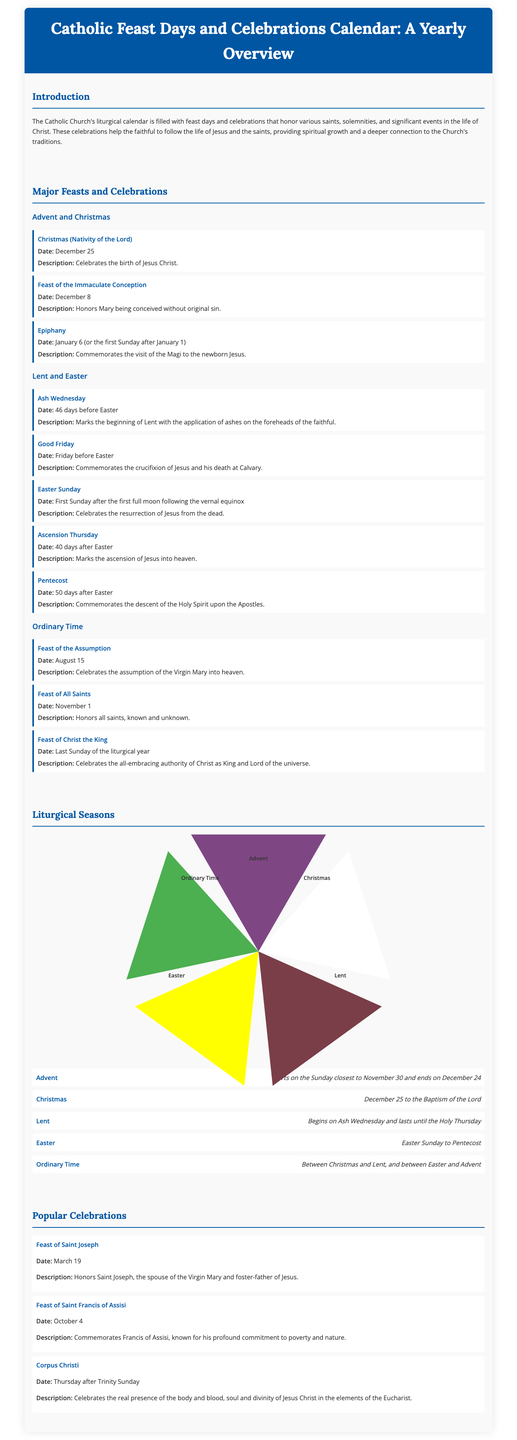what is the date of Christmas? Christmas is celebrated on December 25, as mentioned in the major feasts section.
Answer: December 25 what feast honors Mary being conceived without original sin? The feast that honors Mary is the Feast of the Immaculate Conception which occurs on December 8.
Answer: Feast of the Immaculate Conception how many days after Easter is Pentecost celebrated? Pentecost is celebrated 50 days after Easter according to the document's explanation.
Answer: 50 days which season starts on the Sunday closest to November 30? The season that starts on that date is Advent, as indicated in the liturgical seasons section.
Answer: Advent what is commemorated on Good Friday? Good Friday commemorates the crucifixion of Jesus and his death at Calvary, as outlined in the events.
Answer: Crucifixion of Jesus which feast is celebrated on August 15? The feast celebrated on this date is the Feast of the Assumption.
Answer: Feast of the Assumption when does Ordinary Time occur? Ordinary Time occurs between Christmas and Lent, and between Easter and Advent, as described in the liturgical seasons.
Answer: Between Christmas and Lent, and between Easter and Advent what celebration occurs on March 19? The celebration on March 19 is the Feast of Saint Joseph.
Answer: Feast of Saint Joseph 